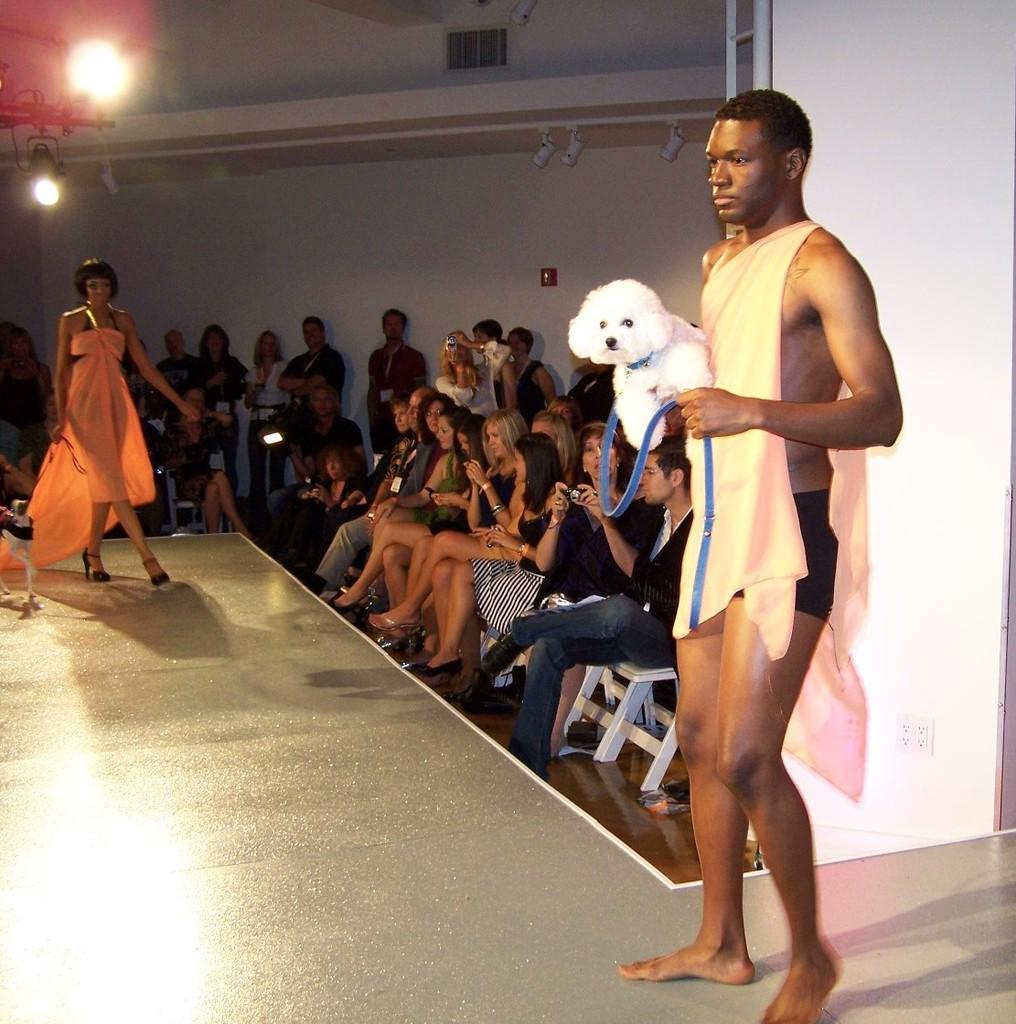What are the people in the image doing? There are people sitting on chairs in the image. Can you describe the interaction between the man and the dog in the image? The man is holding a dog in the image. What is the woman wearing in the image? There is a woman wearing an orange dress in the image. What can be inferred about the weather or time of day in the image? There is a day (likely a sunny day) in the background of the image. Where is the lake located in the image? There is no lake present in the image. What type of map is the man holding in the image? The man is not holding a map in the image; he is holding a dog. 